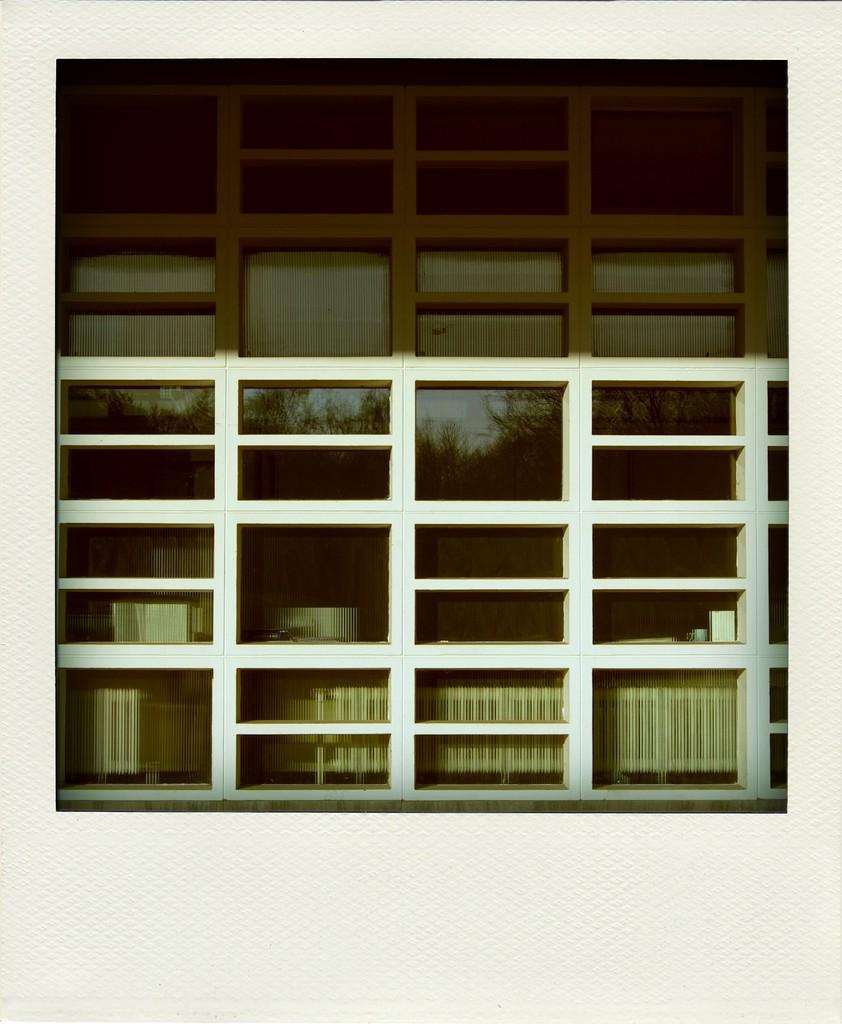What is the primary element visible in the image? There is a window glass in the image. What can be seen through the window glass? Trees are visible in the image. What else can be observed in the image besides the window glass and trees? There are objects in the image. How many plants are being lifted by the expert in the image? There are no plants or experts present in the image. 